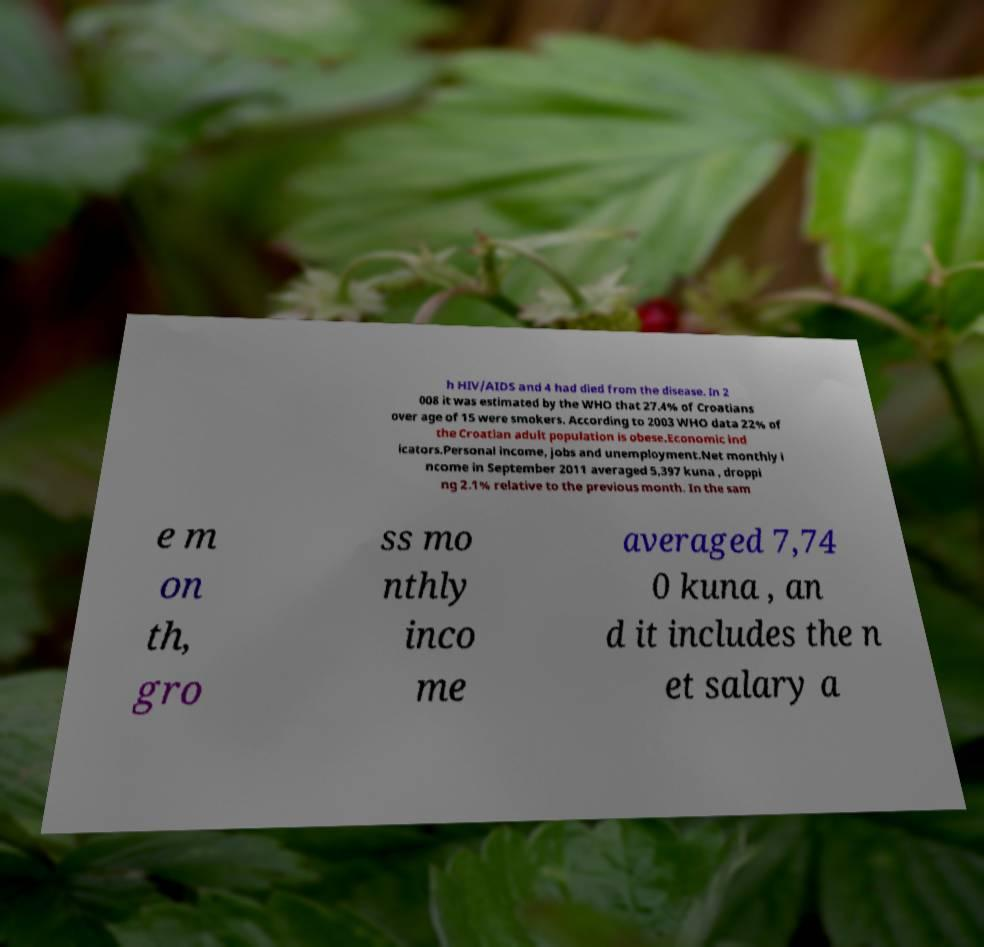For documentation purposes, I need the text within this image transcribed. Could you provide that? h HIV/AIDS and 4 had died from the disease. In 2 008 it was estimated by the WHO that 27.4% of Croatians over age of 15 were smokers. According to 2003 WHO data 22% of the Croatian adult population is obese.Economic ind icators.Personal income, jobs and unemployment.Net monthly i ncome in September 2011 averaged 5,397 kuna , droppi ng 2.1% relative to the previous month. In the sam e m on th, gro ss mo nthly inco me averaged 7,74 0 kuna , an d it includes the n et salary a 